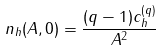Convert formula to latex. <formula><loc_0><loc_0><loc_500><loc_500>n _ { h } ( A , 0 ) = \frac { ( q - 1 ) c _ { h } ^ { ( q ) } } { A ^ { 2 } }</formula> 